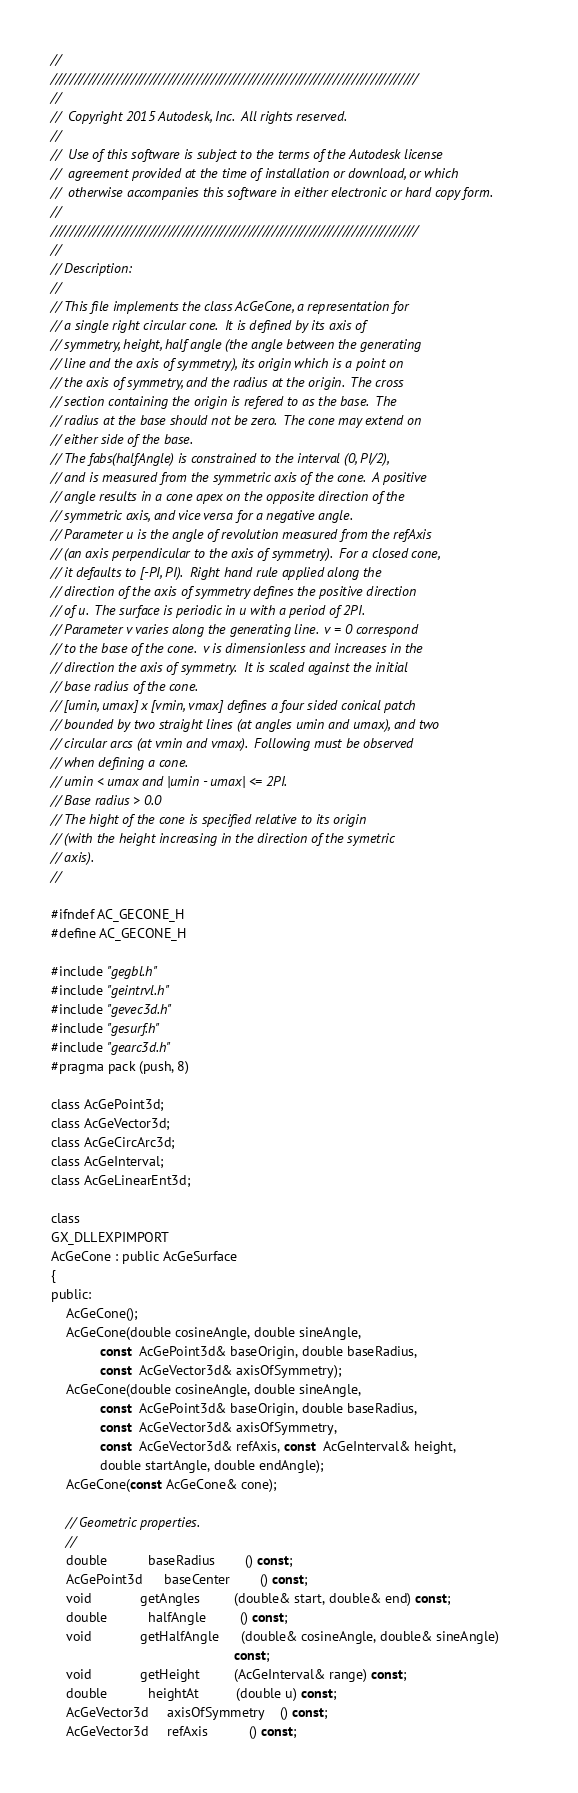Convert code to text. <code><loc_0><loc_0><loc_500><loc_500><_C_>//
//////////////////////////////////////////////////////////////////////////////
//
//  Copyright 2015 Autodesk, Inc.  All rights reserved.
//
//  Use of this software is subject to the terms of the Autodesk license 
//  agreement provided at the time of installation or download, or which 
//  otherwise accompanies this software in either electronic or hard copy form.   
//
//////////////////////////////////////////////////////////////////////////////
//
// Description:
//
// This file implements the class AcGeCone, a representation for
// a single right circular cone.  It is defined by its axis of
// symmetry, height, half angle (the angle between the generating
// line and the axis of symmetry), its origin which is a point on
// the axis of symmetry, and the radius at the origin.  The cross
// section containing the origin is refered to as the base.  The
// radius at the base should not be zero.  The cone may extend on
// either side of the base.
// The fabs(halfAngle) is constrained to the interval (0, PI/2),
// and is measured from the symmetric axis of the cone.  A positive
// angle results in a cone apex on the opposite direction of the
// symmetric axis, and vice versa for a negative angle.
// Parameter u is the angle of revolution measured from the refAxis
// (an axis perpendicular to the axis of symmetry).  For a closed cone,
// it defaults to [-PI, PI).  Right hand rule applied along the
// direction of the axis of symmetry defines the positive direction
// of u.  The surface is periodic in u with a period of 2PI.
// Parameter v varies along the generating line.  v = 0 correspond
// to the base of the cone.  v is dimensionless and increases in the
// direction the axis of symmetry.  It is scaled against the initial
// base radius of the cone.
// [umin, umax] x [vmin, vmax] defines a four sided conical patch
// bounded by two straight lines (at angles umin and umax), and two
// circular arcs (at vmin and vmax).  Following must be observed
// when defining a cone.
// umin < umax and |umin - umax| <= 2PI.
// Base radius > 0.0
// The hight of the cone is specified relative to its origin
// (with the height increasing in the direction of the symetric
// axis).
//

#ifndef AC_GECONE_H
#define AC_GECONE_H

#include "gegbl.h"
#include "geintrvl.h"
#include "gevec3d.h"
#include "gesurf.h"
#include "gearc3d.h"
#pragma pack (push, 8)

class AcGePoint3d;
class AcGeVector3d;
class AcGeCircArc3d;
class AcGeInterval;
class AcGeLinearEnt3d;

class 
GX_DLLEXPIMPORT
AcGeCone : public AcGeSurface
{
public:
    AcGeCone();
    AcGeCone(double cosineAngle, double sineAngle,
             const  AcGePoint3d& baseOrigin, double baseRadius,
             const  AcGeVector3d& axisOfSymmetry);
    AcGeCone(double cosineAngle, double sineAngle,
             const  AcGePoint3d& baseOrigin, double baseRadius,
             const  AcGeVector3d& axisOfSymmetry,
             const  AcGeVector3d& refAxis, const  AcGeInterval& height,
             double startAngle, double endAngle);
    AcGeCone(const AcGeCone& cone);

    // Geometric properties.
    //
    double           baseRadius        () const;
    AcGePoint3d      baseCenter        () const;
    void             getAngles         (double& start, double& end) const;
    double           halfAngle         () const;
    void             getHalfAngle      (double& cosineAngle, double& sineAngle)
                                                 const;
    void             getHeight         (AcGeInterval& range) const;
    double           heightAt          (double u) const;
    AcGeVector3d     axisOfSymmetry    () const;
    AcGeVector3d     refAxis           () const;</code> 